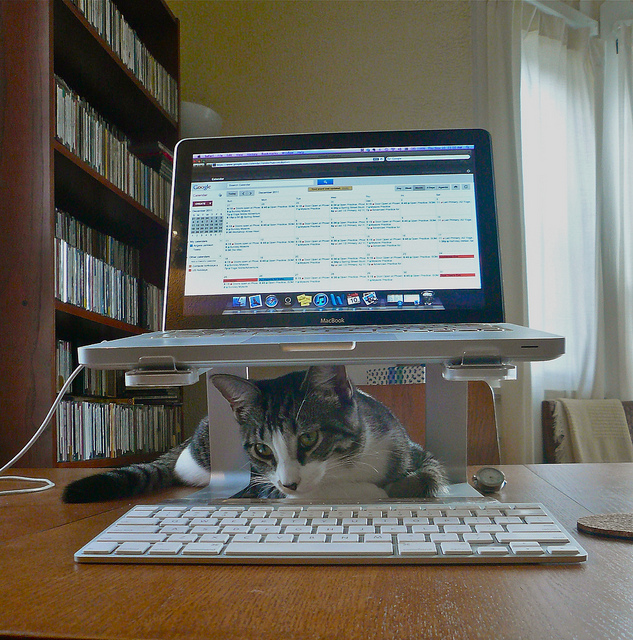Read and extract the text from this image. MacBook 